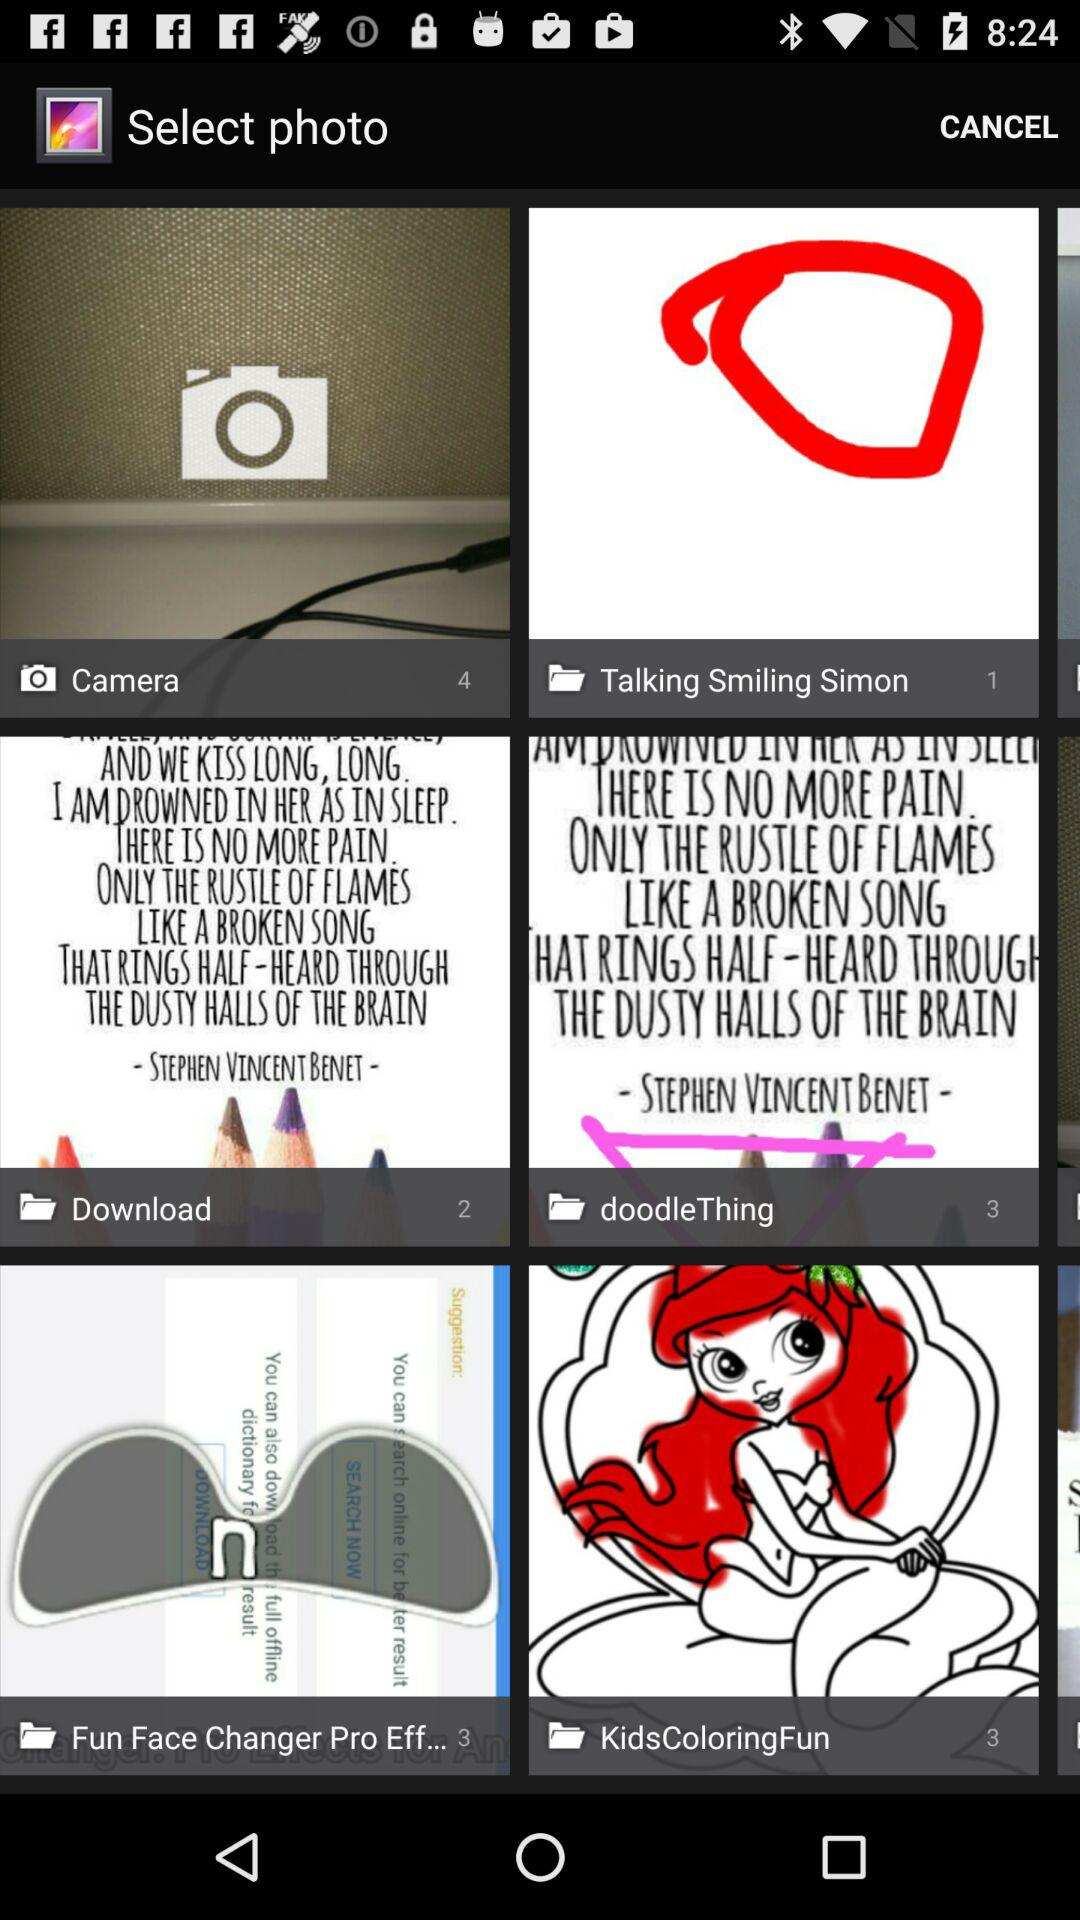How many files are in the download folder? There are 2 files in the download folder. 